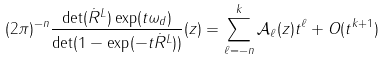Convert formula to latex. <formula><loc_0><loc_0><loc_500><loc_500>( 2 \pi ) ^ { - n } \frac { \det ( \dot { R } ^ { L } ) \exp ( t \omega _ { d } ) } { \det ( 1 - \exp ( - t \dot { R } ^ { L } ) ) } ( z ) = \sum _ { \ell = - n } ^ { k } \mathcal { A } _ { \ell } ( z ) t ^ { \ell } + O ( t ^ { k + 1 } )</formula> 